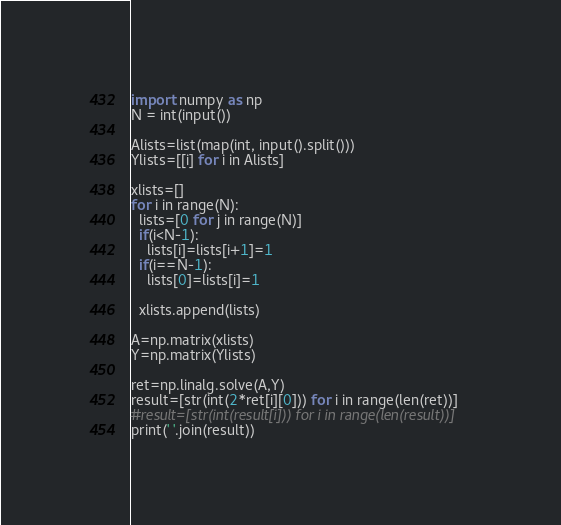<code> <loc_0><loc_0><loc_500><loc_500><_Python_>import numpy as np
N = int(input())

Alists=list(map(int, input().split()))
Ylists=[[i] for i in Alists]

xlists=[]
for i in range(N):
  lists=[0 for j in range(N)]
  if(i<N-1):
    lists[i]=lists[i+1]=1
  if(i==N-1):
    lists[0]=lists[i]=1
    
  xlists.append(lists)

A=np.matrix(xlists)
Y=np.matrix(Ylists)

ret=np.linalg.solve(A,Y)
result=[str(int(2*ret[i][0])) for i in range(len(ret))]
#result=[str(int(result[i])) for i in range(len(result))]
print(' '.join(result))</code> 